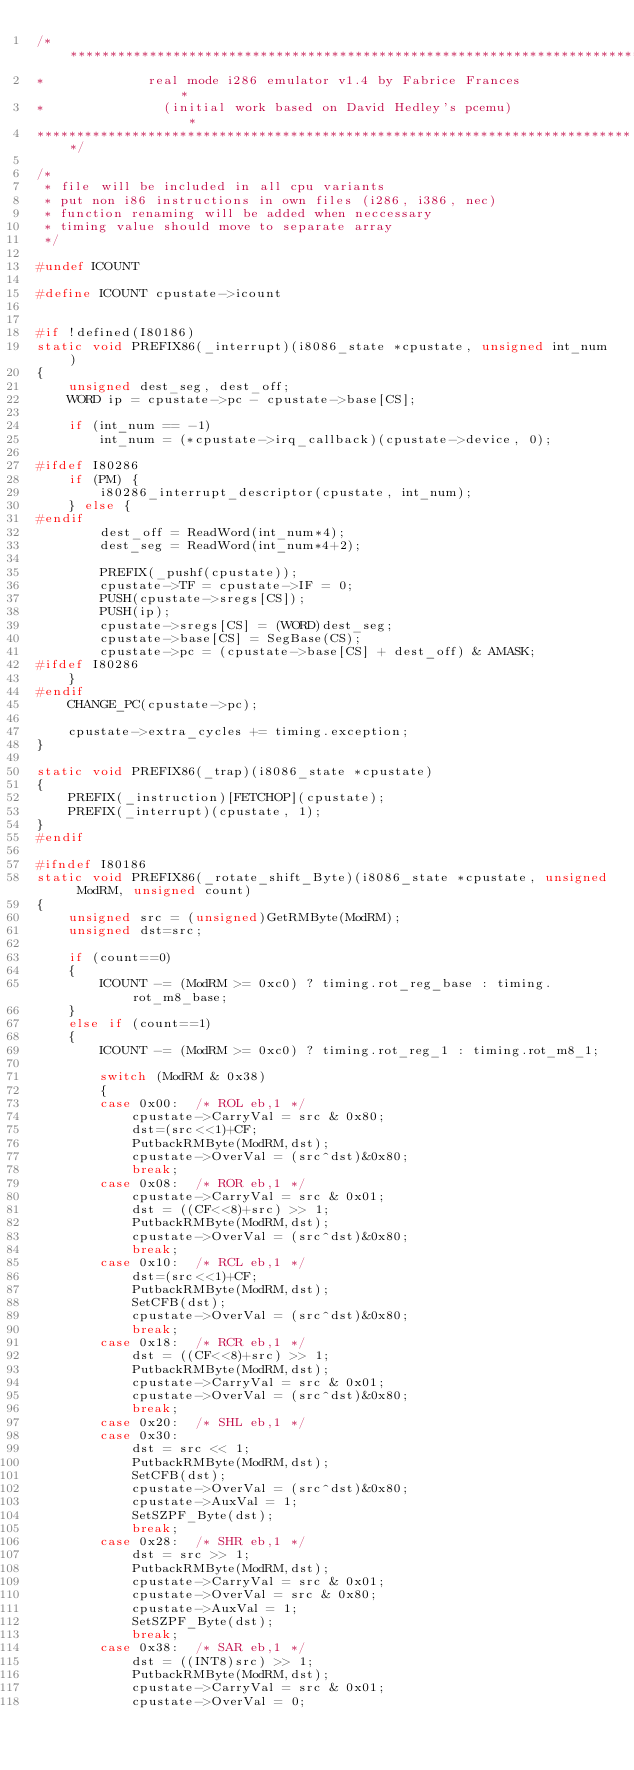<code> <loc_0><loc_0><loc_500><loc_500><_C_>/****************************************************************************
*             real mode i286 emulator v1.4 by Fabrice Frances               *
*               (initial work based on David Hedley's pcemu)                *
****************************************************************************/

/*
 * file will be included in all cpu variants
 * put non i86 instructions in own files (i286, i386, nec)
 * function renaming will be added when neccessary
 * timing value should move to separate array
 */

#undef ICOUNT

#define ICOUNT cpustate->icount


#if !defined(I80186)
static void PREFIX86(_interrupt)(i8086_state *cpustate, unsigned int_num)
{
	unsigned dest_seg, dest_off;
	WORD ip = cpustate->pc - cpustate->base[CS];

	if (int_num == -1)
		int_num = (*cpustate->irq_callback)(cpustate->device, 0);

#ifdef I80286
	if (PM) {
		i80286_interrupt_descriptor(cpustate, int_num);
	} else {
#endif
		dest_off = ReadWord(int_num*4);
		dest_seg = ReadWord(int_num*4+2);

		PREFIX(_pushf(cpustate));
		cpustate->TF = cpustate->IF = 0;
		PUSH(cpustate->sregs[CS]);
		PUSH(ip);
		cpustate->sregs[CS] = (WORD)dest_seg;
		cpustate->base[CS] = SegBase(CS);
		cpustate->pc = (cpustate->base[CS] + dest_off) & AMASK;
#ifdef I80286
	}
#endif
	CHANGE_PC(cpustate->pc);

	cpustate->extra_cycles += timing.exception;
}

static void PREFIX86(_trap)(i8086_state *cpustate)
{
	PREFIX(_instruction)[FETCHOP](cpustate);
	PREFIX(_interrupt)(cpustate, 1);
}
#endif

#ifndef I80186
static void PREFIX86(_rotate_shift_Byte)(i8086_state *cpustate, unsigned ModRM, unsigned count)
{
	unsigned src = (unsigned)GetRMByte(ModRM);
	unsigned dst=src;

	if (count==0)
	{
		ICOUNT -= (ModRM >= 0xc0) ? timing.rot_reg_base : timing.rot_m8_base;
	}
	else if (count==1)
	{
		ICOUNT -= (ModRM >= 0xc0) ? timing.rot_reg_1 : timing.rot_m8_1;

		switch (ModRM & 0x38)
		{
		case 0x00:	/* ROL eb,1 */
			cpustate->CarryVal = src & 0x80;
			dst=(src<<1)+CF;
			PutbackRMByte(ModRM,dst);
			cpustate->OverVal = (src^dst)&0x80;
			break;
		case 0x08:	/* ROR eb,1 */
			cpustate->CarryVal = src & 0x01;
			dst = ((CF<<8)+src) >> 1;
			PutbackRMByte(ModRM,dst);
			cpustate->OverVal = (src^dst)&0x80;
			break;
		case 0x10:	/* RCL eb,1 */
			dst=(src<<1)+CF;
			PutbackRMByte(ModRM,dst);
			SetCFB(dst);
			cpustate->OverVal = (src^dst)&0x80;
			break;
		case 0x18:	/* RCR eb,1 */
			dst = ((CF<<8)+src) >> 1;
			PutbackRMByte(ModRM,dst);
			cpustate->CarryVal = src & 0x01;
			cpustate->OverVal = (src^dst)&0x80;
			break;
		case 0x20:	/* SHL eb,1 */
		case 0x30:
			dst = src << 1;
			PutbackRMByte(ModRM,dst);
			SetCFB(dst);
			cpustate->OverVal = (src^dst)&0x80;
			cpustate->AuxVal = 1;
			SetSZPF_Byte(dst);
			break;
		case 0x28:	/* SHR eb,1 */
			dst = src >> 1;
			PutbackRMByte(ModRM,dst);
			cpustate->CarryVal = src & 0x01;
			cpustate->OverVal = src & 0x80;
			cpustate->AuxVal = 1;
			SetSZPF_Byte(dst);
			break;
		case 0x38:	/* SAR eb,1 */
			dst = ((INT8)src) >> 1;
			PutbackRMByte(ModRM,dst);
			cpustate->CarryVal = src & 0x01;
			cpustate->OverVal = 0;</code> 